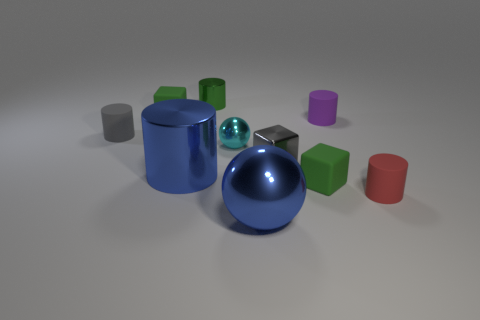Is the size of the thing that is in front of the red object the same as the cyan thing?
Offer a very short reply. No. There is a object that is both on the left side of the tiny metal cylinder and behind the small purple object; what shape is it?
Your response must be concise. Cube. There is a large metal ball; are there any red matte cylinders on the right side of it?
Offer a terse response. Yes. Is there anything else that is the same shape as the red object?
Offer a very short reply. Yes. Is the shape of the small cyan metal object the same as the red rubber object?
Ensure brevity in your answer.  No. Are there the same number of rubber blocks right of the big blue metallic cylinder and tiny matte cubes on the right side of the tiny cyan thing?
Keep it short and to the point. Yes. What number of other things are there of the same material as the purple cylinder
Your response must be concise. 4. How many large objects are either matte objects or brown shiny cubes?
Provide a succinct answer. 0. Are there the same number of blue metal things that are behind the small metal block and green matte things?
Offer a terse response. No. There is a big blue object that is right of the large cylinder; is there a red cylinder that is to the left of it?
Provide a succinct answer. No. 